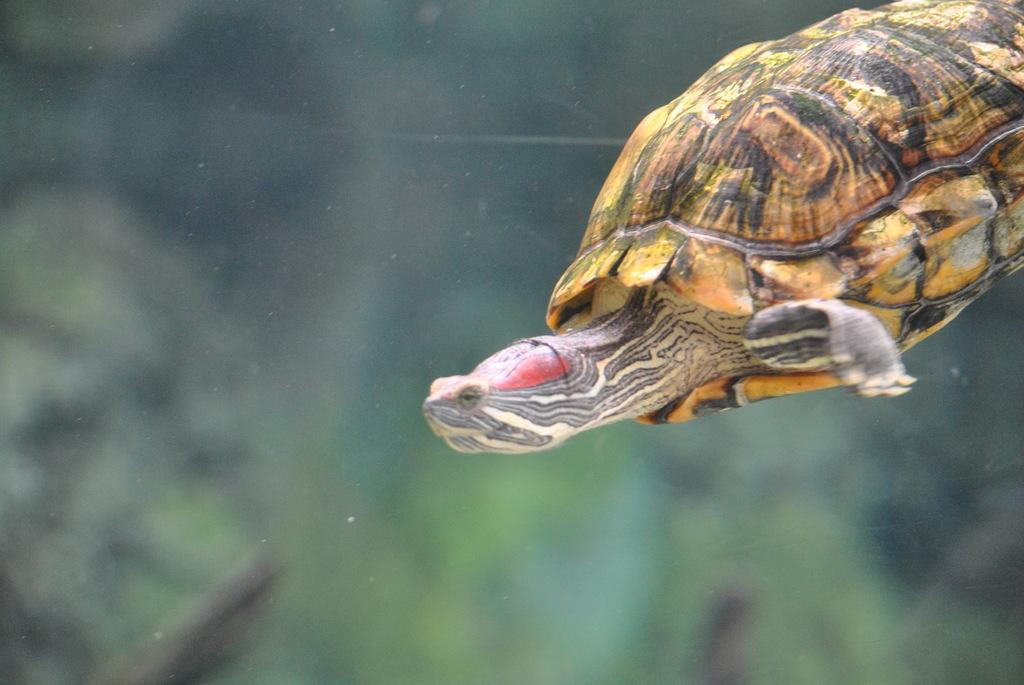What animal is present in the image? There is a turtle in the image. Where is the image likely taken? The image appears to be taken in the water. Can you describe the background of the image? The background of the image is blurred. What type of peace symbol can be seen in the image? There is no peace symbol present in the image; it features a turtle in the water with a blurred background. 